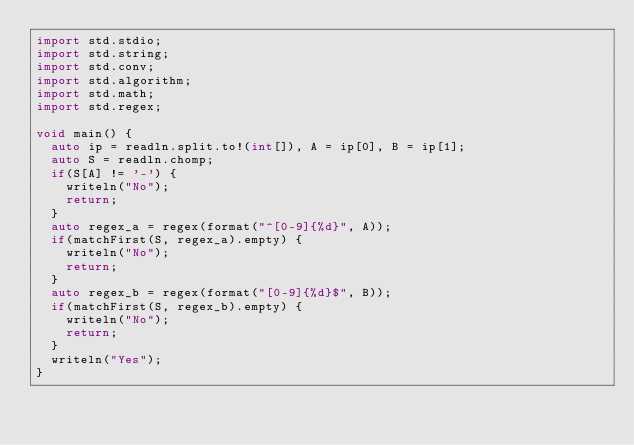<code> <loc_0><loc_0><loc_500><loc_500><_D_>import std.stdio;
import std.string;
import std.conv;
import std.algorithm;
import std.math;
import std.regex;

void main() {
	auto ip = readln.split.to!(int[]), A = ip[0], B = ip[1];
	auto S = readln.chomp;
	if(S[A] != '-') {
		writeln("No");
		return;
	}
	auto regex_a = regex(format("^[0-9]{%d}", A));
	if(matchFirst(S, regex_a).empty) {
		writeln("No");
		return;
	}
	auto regex_b = regex(format("[0-9]{%d}$", B));
	if(matchFirst(S, regex_b).empty) {
		writeln("No");
		return;
	}
	writeln("Yes");
}
</code> 